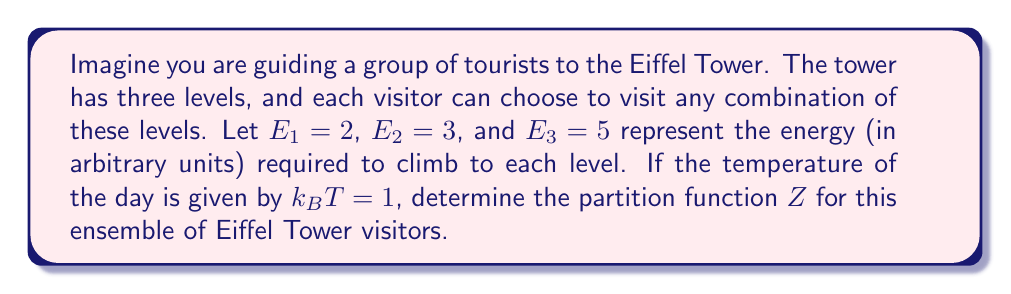Solve this math problem. To solve this problem, let's follow these steps:

1) The partition function $Z$ is defined as the sum of all possible Boltzmann factors:

   $$Z = \sum_i e^{-\beta E_i}$$

   where $\beta = \frac{1}{k_BT}$

2) In this case, $k_BT = 1$, so $\beta = 1$

3) Each visitor has 8 possible states:
   - Not visiting any level (ground level)
   - Visiting only level 1
   - Visiting only level 2
   - Visiting only level 3
   - Visiting levels 1 and 2
   - Visiting levels 1 and 3
   - Visiting levels 2 and 3
   - Visiting all three levels

4) Let's calculate the Boltzmann factor for each state:
   - Ground level: $e^{-0} = 1$
   - Level 1 only: $e^{-2}$
   - Level 2 only: $e^{-3}$
   - Level 3 only: $e^{-5}$
   - Levels 1 and 2: $e^{-(2+3)} = e^{-5}$
   - Levels 1 and 3: $e^{-(2+5)} = e^{-7}$
   - Levels 2 and 3: $e^{-(3+5)} = e^{-8}$
   - All levels: $e^{-(2+3+5)} = e^{-10}$

5) The partition function is the sum of all these factors:

   $$Z = 1 + e^{-2} + e^{-3} + e^{-5} + e^{-5} + e^{-7} + e^{-8} + e^{-10}$$

6) Simplifying:

   $$Z = 1 + e^{-2} + e^{-3} + 2e^{-5} + e^{-7} + e^{-8} + e^{-10}$$

This is the partition function for the ensemble of Eiffel Tower visitors.
Answer: $Z = 1 + e^{-2} + e^{-3} + 2e^{-5} + e^{-7} + e^{-8} + e^{-10}$ 